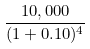Convert formula to latex. <formula><loc_0><loc_0><loc_500><loc_500>\frac { 1 0 , 0 0 0 } { ( 1 + 0 . 1 0 ) ^ { 4 } }</formula> 